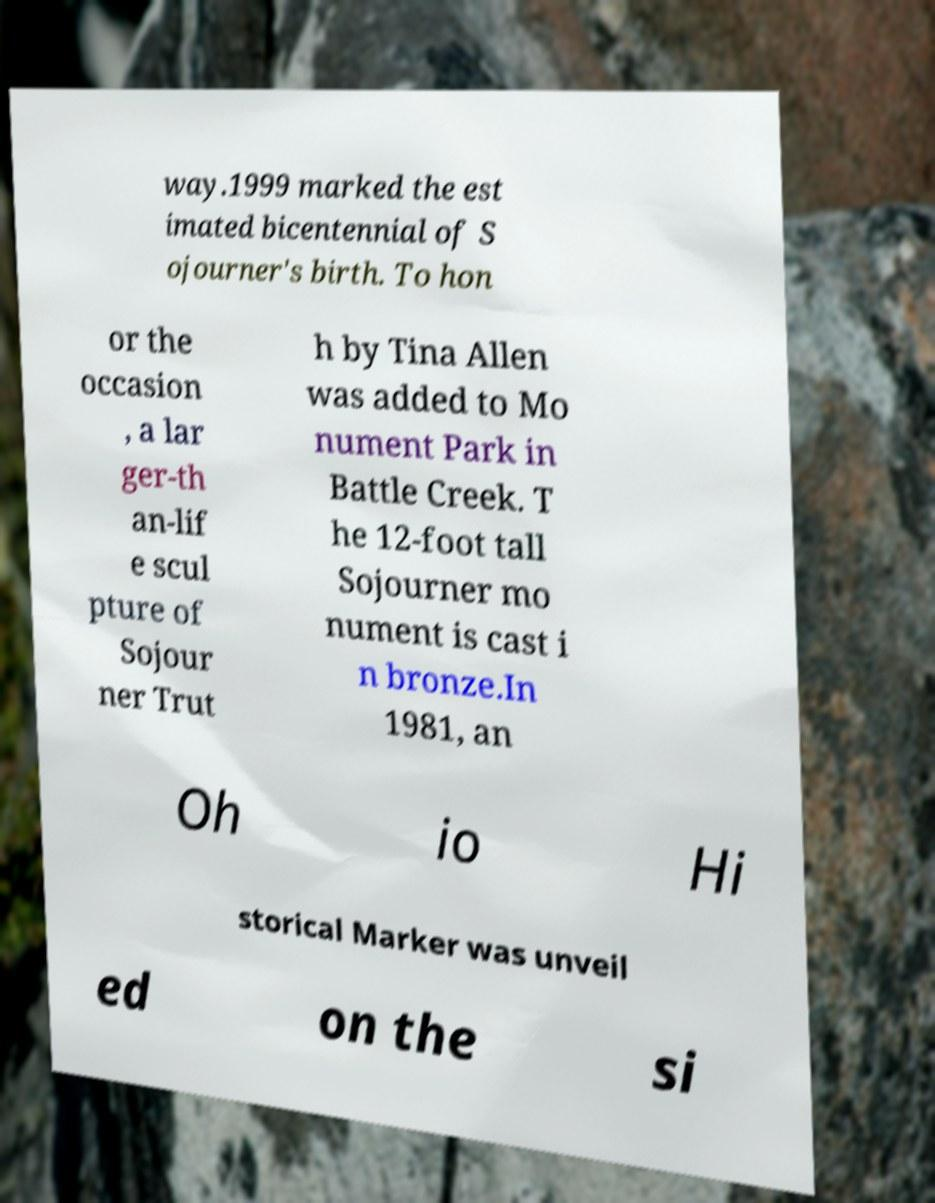Could you extract and type out the text from this image? way.1999 marked the est imated bicentennial of S ojourner's birth. To hon or the occasion , a lar ger-th an-lif e scul pture of Sojour ner Trut h by Tina Allen was added to Mo nument Park in Battle Creek. T he 12-foot tall Sojourner mo nument is cast i n bronze.In 1981, an Oh io Hi storical Marker was unveil ed on the si 